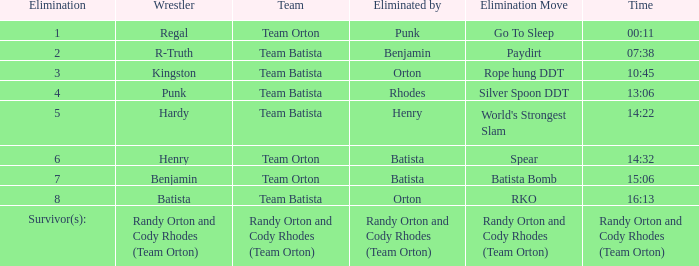What Elimination Move is listed against Wrestler Henry, Eliminated by Batista? Spear. 